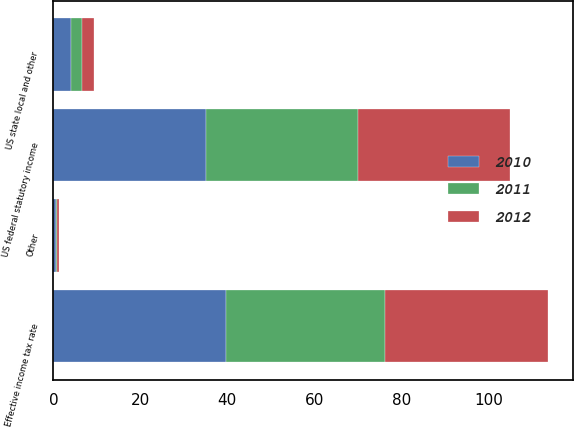Convert chart. <chart><loc_0><loc_0><loc_500><loc_500><stacked_bar_chart><ecel><fcel>US federal statutory income<fcel>US state local and other<fcel>Other<fcel>Effective income tax rate<nl><fcel>2012<fcel>35<fcel>2.9<fcel>0.4<fcel>37.5<nl><fcel>2011<fcel>35<fcel>2.4<fcel>0.2<fcel>36.6<nl><fcel>2010<fcel>35<fcel>4.1<fcel>0.6<fcel>39.7<nl></chart> 